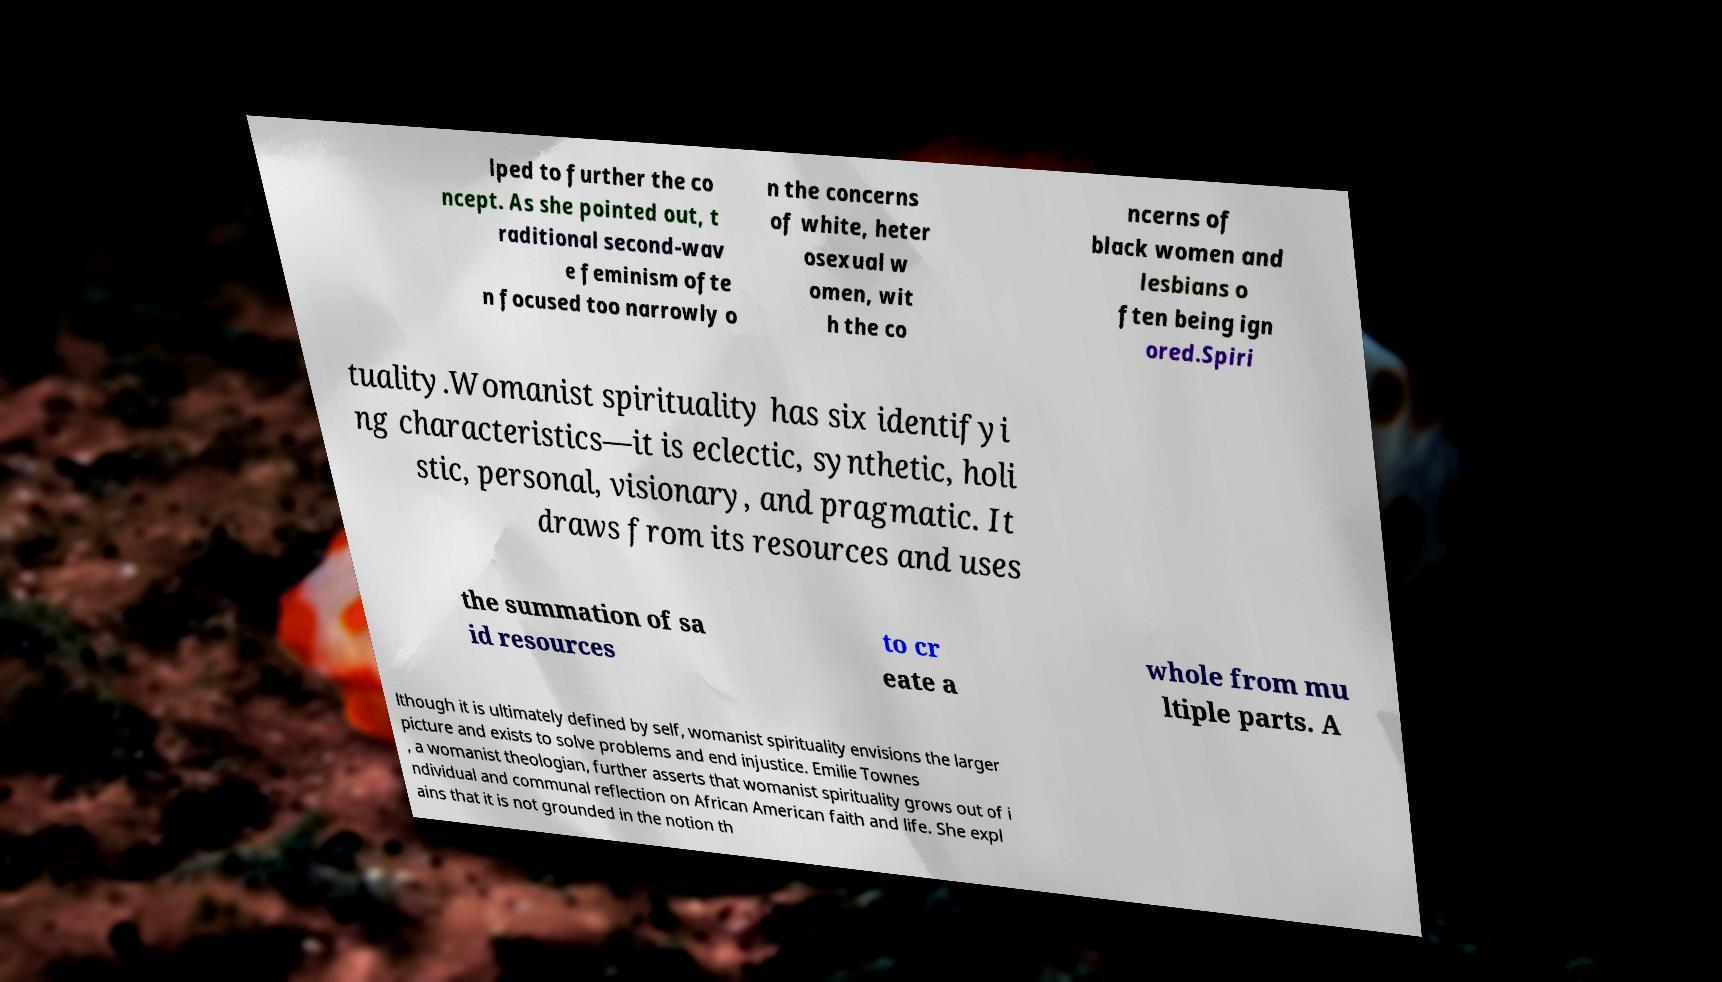There's text embedded in this image that I need extracted. Can you transcribe it verbatim? lped to further the co ncept. As she pointed out, t raditional second-wav e feminism ofte n focused too narrowly o n the concerns of white, heter osexual w omen, wit h the co ncerns of black women and lesbians o ften being ign ored.Spiri tuality.Womanist spirituality has six identifyi ng characteristics—it is eclectic, synthetic, holi stic, personal, visionary, and pragmatic. It draws from its resources and uses the summation of sa id resources to cr eate a whole from mu ltiple parts. A lthough it is ultimately defined by self, womanist spirituality envisions the larger picture and exists to solve problems and end injustice. Emilie Townes , a womanist theologian, further asserts that womanist spirituality grows out of i ndividual and communal reflection on African American faith and life. She expl ains that it is not grounded in the notion th 